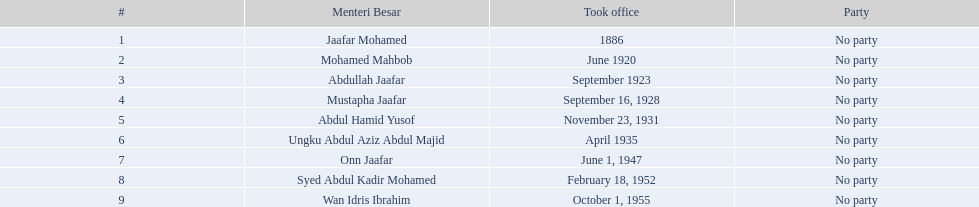Give me the full table as a dictionary. {'header': ['#', 'Menteri Besar', 'Took office', 'Party'], 'rows': [['1', 'Jaafar Mohamed', '1886', 'No party'], ['2', 'Mohamed Mahbob', 'June 1920', 'No party'], ['3', 'Abdullah Jaafar', 'September 1923', 'No party'], ['4', 'Mustapha Jaafar', 'September 16, 1928', 'No party'], ['5', 'Abdul Hamid Yusof', 'November 23, 1931', 'No party'], ['6', 'Ungku Abdul Aziz Abdul Majid', 'April 1935', 'No party'], ['7', 'Onn Jaafar', 'June 1, 1947', 'No party'], ['8', 'Syed Abdul Kadir Mohamed', 'February 18, 1952', 'No party'], ['9', 'Wan Idris Ibrahim', 'October 1, 1955', 'No party']]} For what duration did ungku abdul aziz abdul majid hold his position? 12 years. 